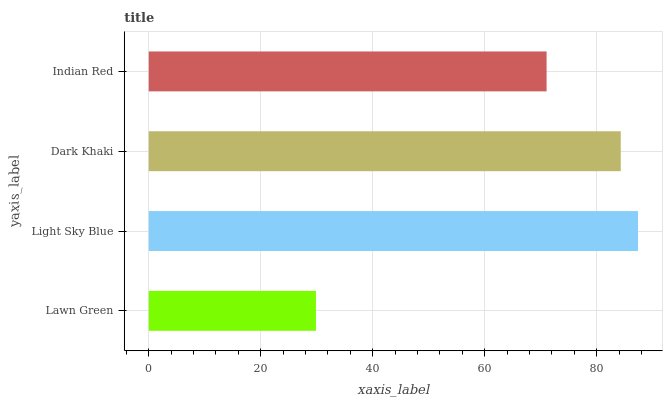Is Lawn Green the minimum?
Answer yes or no. Yes. Is Light Sky Blue the maximum?
Answer yes or no. Yes. Is Dark Khaki the minimum?
Answer yes or no. No. Is Dark Khaki the maximum?
Answer yes or no. No. Is Light Sky Blue greater than Dark Khaki?
Answer yes or no. Yes. Is Dark Khaki less than Light Sky Blue?
Answer yes or no. Yes. Is Dark Khaki greater than Light Sky Blue?
Answer yes or no. No. Is Light Sky Blue less than Dark Khaki?
Answer yes or no. No. Is Dark Khaki the high median?
Answer yes or no. Yes. Is Indian Red the low median?
Answer yes or no. Yes. Is Light Sky Blue the high median?
Answer yes or no. No. Is Light Sky Blue the low median?
Answer yes or no. No. 